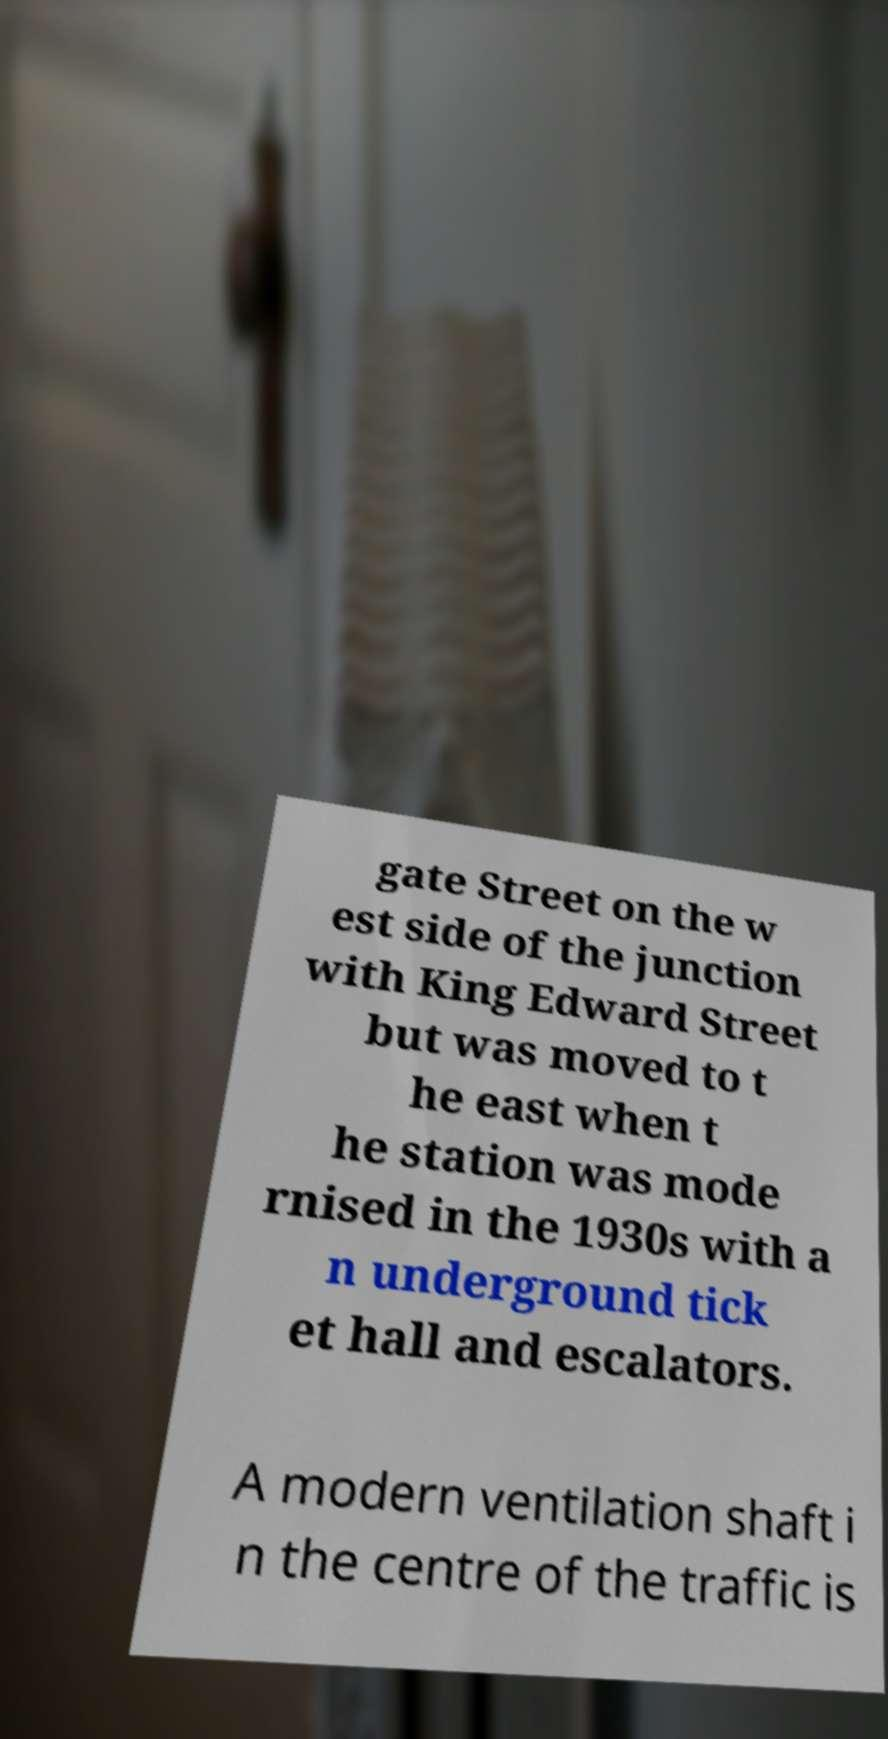Please read and relay the text visible in this image. What does it say? gate Street on the w est side of the junction with King Edward Street but was moved to t he east when t he station was mode rnised in the 1930s with a n underground tick et hall and escalators. A modern ventilation shaft i n the centre of the traffic is 